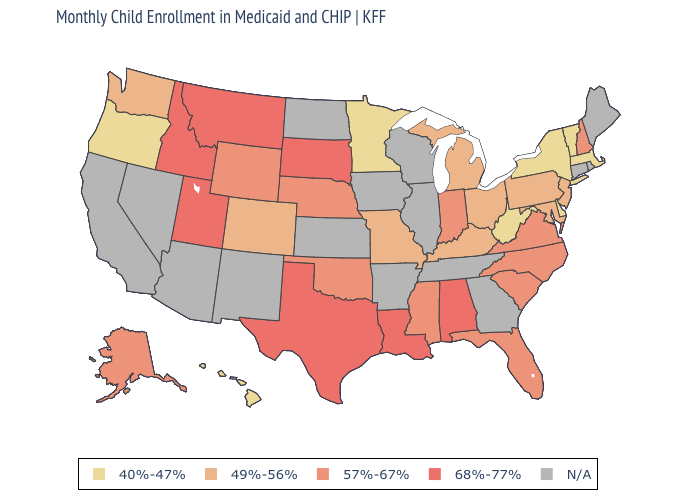What is the highest value in the Northeast ?
Answer briefly. 57%-67%. What is the value of North Dakota?
Quick response, please. N/A. What is the highest value in states that border Missouri?
Give a very brief answer. 57%-67%. Does Texas have the highest value in the USA?
Concise answer only. Yes. Which states have the lowest value in the USA?
Quick response, please. Delaware, Hawaii, Massachusetts, Minnesota, New York, Oregon, Vermont, West Virginia. What is the value of Montana?
Answer briefly. 68%-77%. Name the states that have a value in the range 57%-67%?
Be succinct. Alaska, Florida, Indiana, Mississippi, Nebraska, New Hampshire, North Carolina, Oklahoma, South Carolina, Virginia, Wyoming. Which states have the lowest value in the USA?
Be succinct. Delaware, Hawaii, Massachusetts, Minnesota, New York, Oregon, Vermont, West Virginia. Among the states that border New York , does New Jersey have the lowest value?
Short answer required. No. Name the states that have a value in the range 57%-67%?
Answer briefly. Alaska, Florida, Indiana, Mississippi, Nebraska, New Hampshire, North Carolina, Oklahoma, South Carolina, Virginia, Wyoming. Name the states that have a value in the range 40%-47%?
Be succinct. Delaware, Hawaii, Massachusetts, Minnesota, New York, Oregon, Vermont, West Virginia. What is the value of Arkansas?
Answer briefly. N/A. 